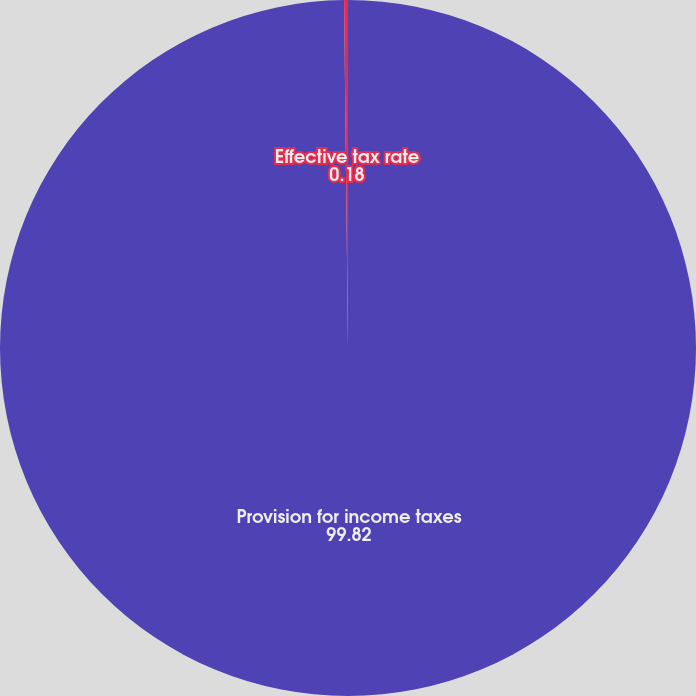Convert chart. <chart><loc_0><loc_0><loc_500><loc_500><pie_chart><fcel>Provision for income taxes<fcel>Effective tax rate<nl><fcel>99.82%<fcel>0.18%<nl></chart> 